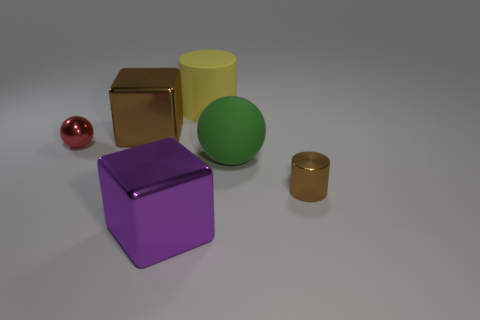Add 2 yellow matte objects. How many objects exist? 8 Subtract all balls. How many objects are left? 4 Subtract all green metal cylinders. Subtract all big green objects. How many objects are left? 5 Add 5 brown blocks. How many brown blocks are left? 6 Add 4 big cyan shiny cylinders. How many big cyan shiny cylinders exist? 4 Subtract 0 green blocks. How many objects are left? 6 